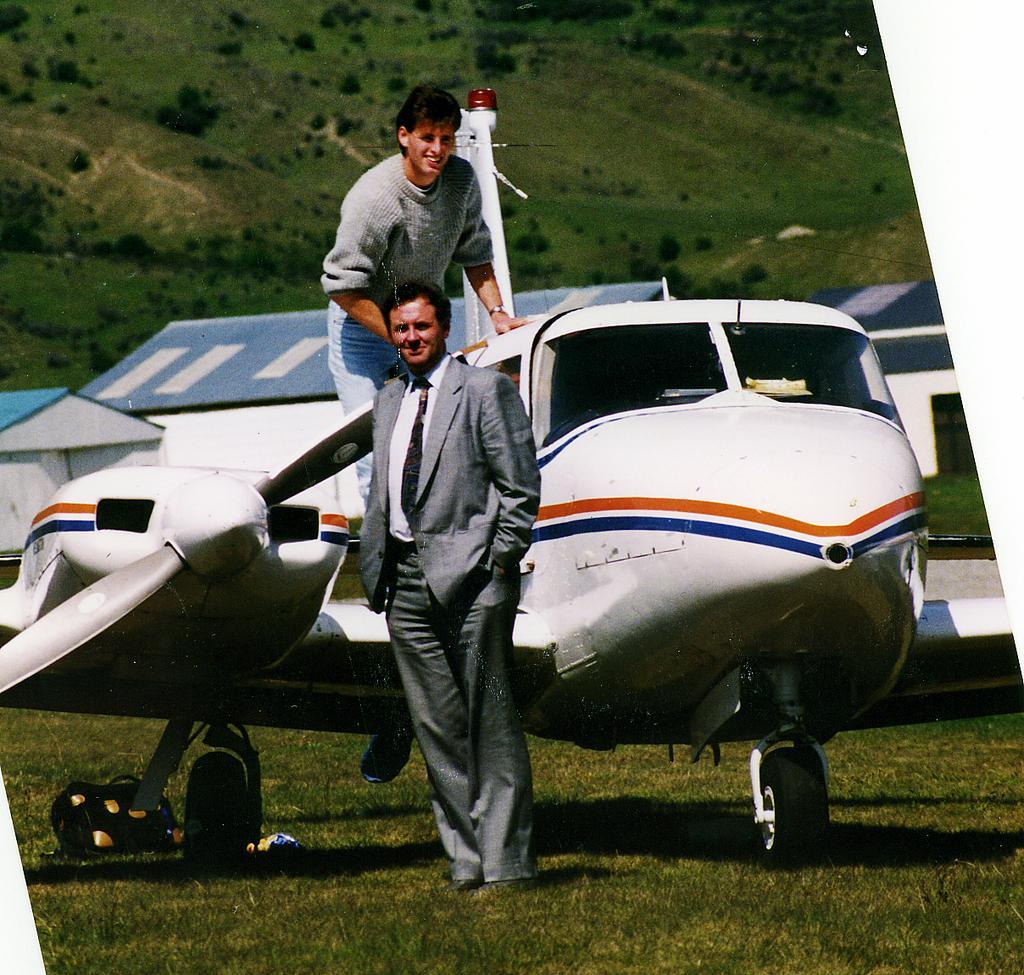In one or two sentences, can you explain what this image depicts? In this image we can see a person standing on the ground. One person is standing on an airplane placed on the grass field. In the background, we can see a bag, a group of houses with roof. At the top of the image we can see some trees. 